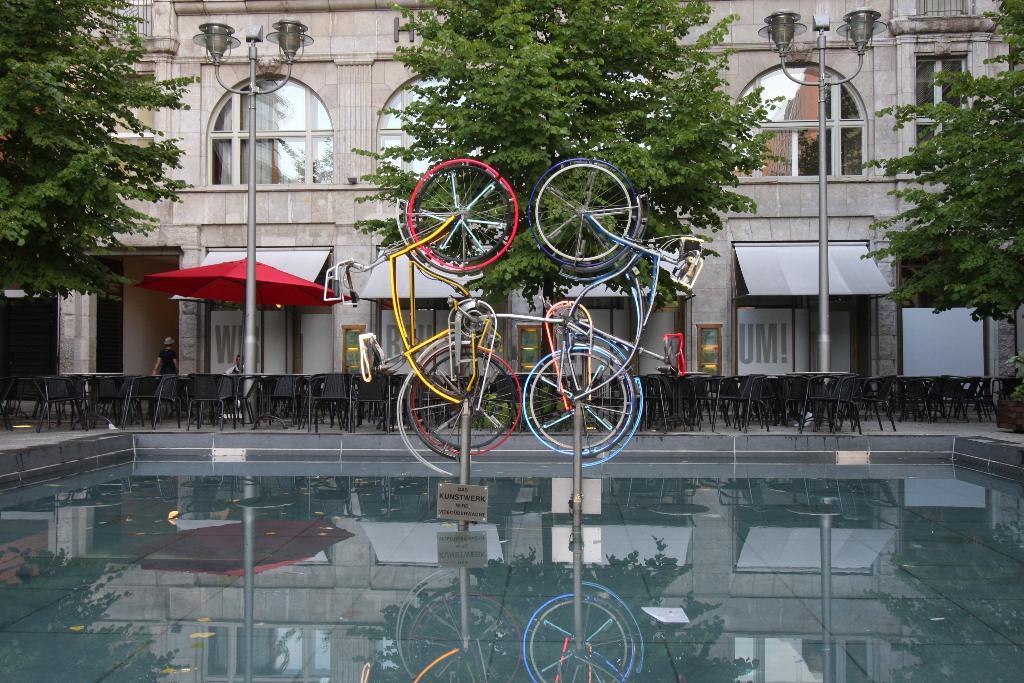In one or two sentences, can you explain what this image depicts? This picture is clicked outside. In the foreground we can see a water body and we can see the bicycles, lamp posts, trees, umbrella, chairs, tables and a person sitting on the chair and a person seems to be walking on the ground. In the background we can see the building and we can see some objects in the background. 